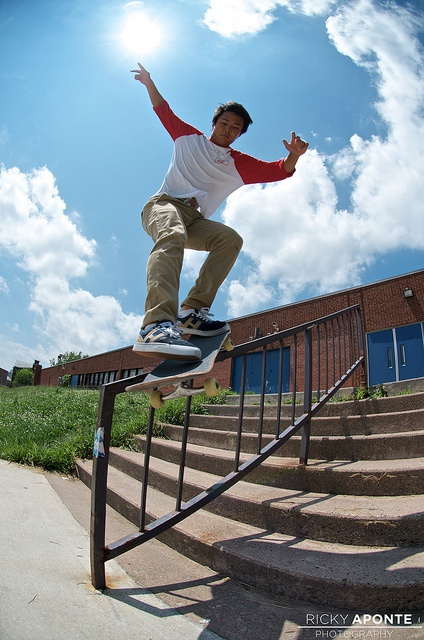Describe the objects in this image and their specific colors. I can see people in teal, darkgray, maroon, gray, and black tones and skateboard in teal, black, gray, and darkgray tones in this image. 